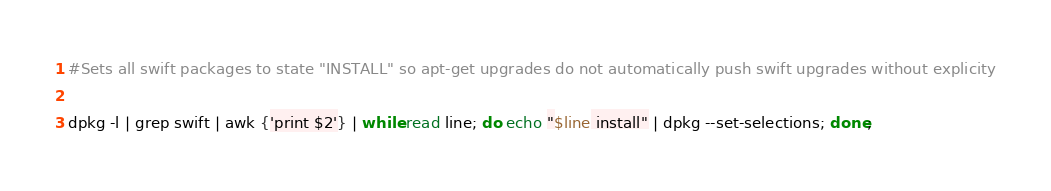<code> <loc_0><loc_0><loc_500><loc_500><_Bash_>#Sets all swift packages to state "INSTALL" so apt-get upgrades do not automatically push swift upgrades without explicity

dpkg -l | grep swift | awk {'print $2'} | while read line; do echo "$line install" | dpkg --set-selections; done;
</code> 